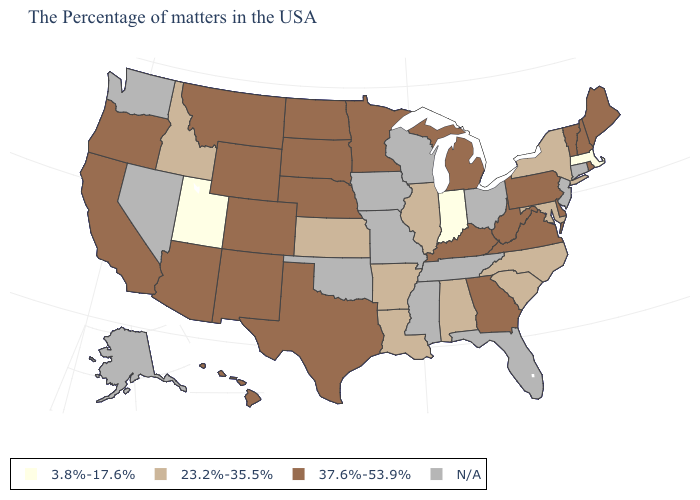Does Massachusetts have the lowest value in the USA?
Write a very short answer. Yes. Name the states that have a value in the range 23.2%-35.5%?
Keep it brief. New York, Maryland, North Carolina, South Carolina, Alabama, Illinois, Louisiana, Arkansas, Kansas, Idaho. What is the value of New Hampshire?
Short answer required. 37.6%-53.9%. Does Alabama have the lowest value in the South?
Short answer required. Yes. Among the states that border Wyoming , which have the highest value?
Be succinct. Nebraska, South Dakota, Colorado, Montana. Name the states that have a value in the range N/A?
Short answer required. Connecticut, New Jersey, Ohio, Florida, Tennessee, Wisconsin, Mississippi, Missouri, Iowa, Oklahoma, Nevada, Washington, Alaska. What is the value of Georgia?
Write a very short answer. 37.6%-53.9%. What is the value of Wyoming?
Be succinct. 37.6%-53.9%. What is the value of Arkansas?
Be succinct. 23.2%-35.5%. What is the value of Oklahoma?
Answer briefly. N/A. Name the states that have a value in the range 3.8%-17.6%?
Answer briefly. Massachusetts, Indiana, Utah. Name the states that have a value in the range N/A?
Be succinct. Connecticut, New Jersey, Ohio, Florida, Tennessee, Wisconsin, Mississippi, Missouri, Iowa, Oklahoma, Nevada, Washington, Alaska. Name the states that have a value in the range 23.2%-35.5%?
Be succinct. New York, Maryland, North Carolina, South Carolina, Alabama, Illinois, Louisiana, Arkansas, Kansas, Idaho. Which states have the lowest value in the West?
Keep it brief. Utah. Does the map have missing data?
Give a very brief answer. Yes. 